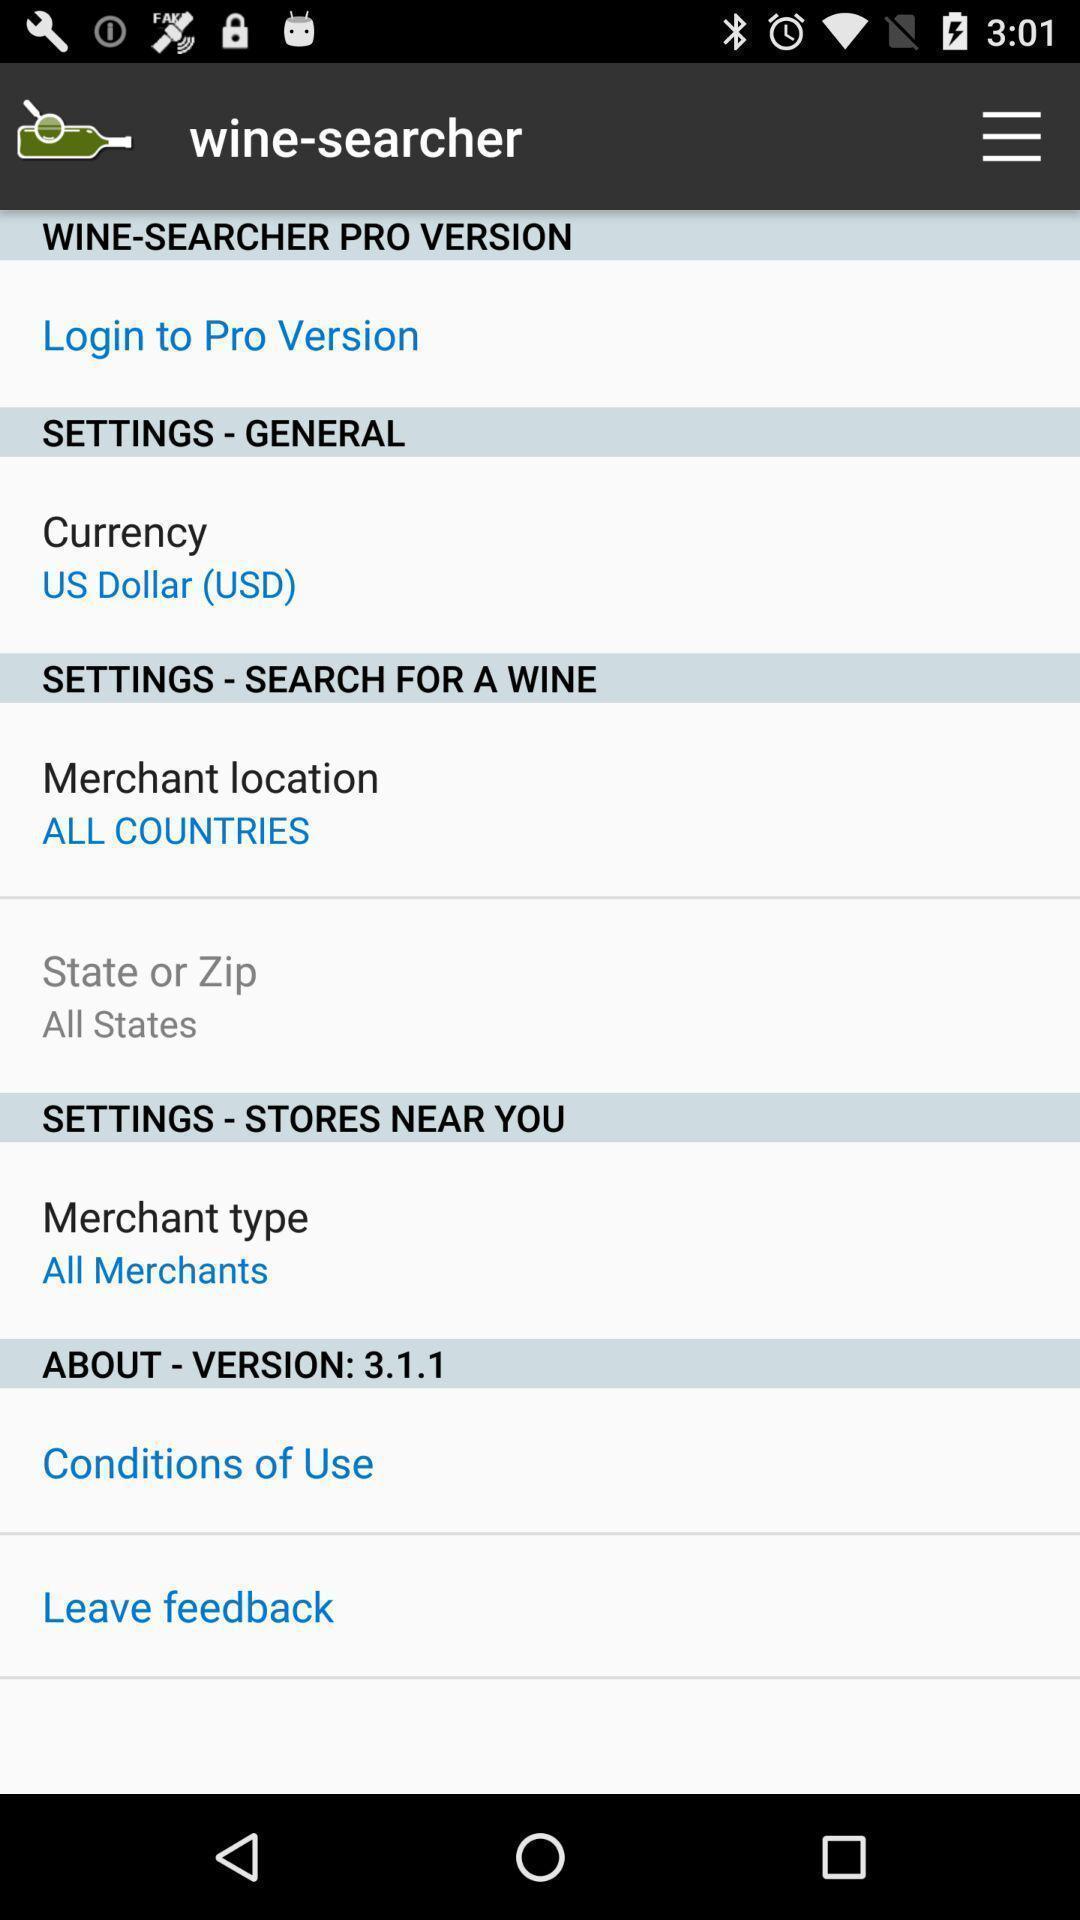Give me a summary of this screen capture. Screen showing various setting options. 